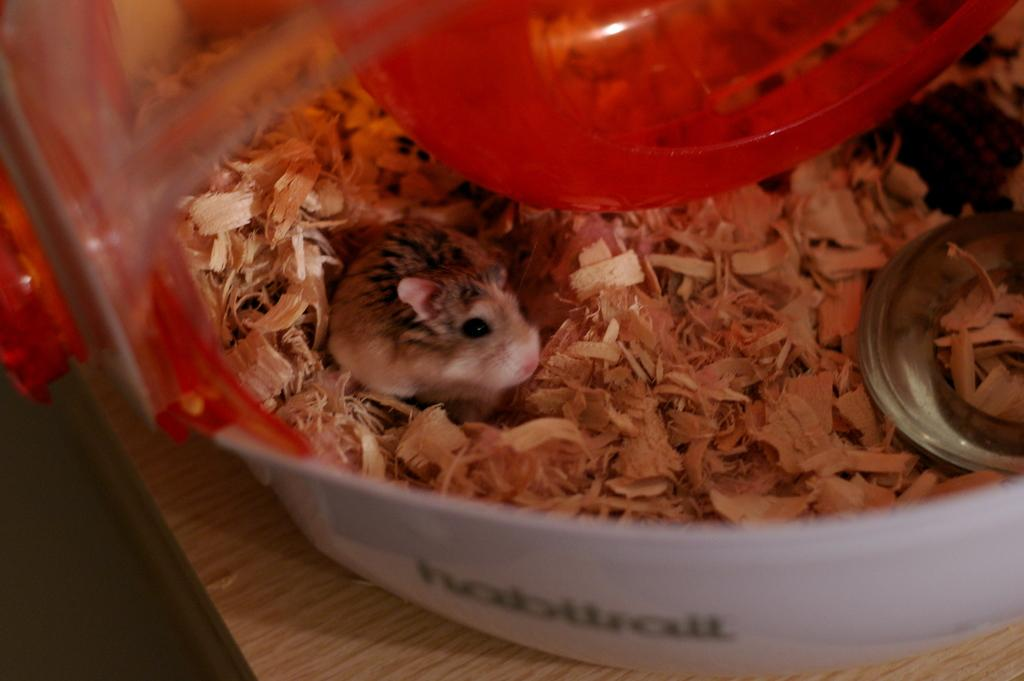What animal is present in the image? There is a rat in the image. Where is the rat located? The rat is in a bowl. What is inside the bowl with the rat? The bowl contains wooden ships. What type of material is the plate in the image made of? The plate in the image is made of metal. What color is the cap in the image? The cap in the image is red. On what surface are all the objects placed? The objects mentioned are placed on a table. Can you see any waves or coastline in the image? No, there are no waves or coastline present in the image. Is there any agreement being signed or discussed in the image? No, there is no mention of an agreement or any discussion related to it in the image. 